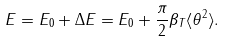Convert formula to latex. <formula><loc_0><loc_0><loc_500><loc_500>E = E _ { 0 } + \Delta E = E _ { 0 } + \frac { \pi } { 2 } \beta _ { T } \langle \theta ^ { 2 } \rangle .</formula> 